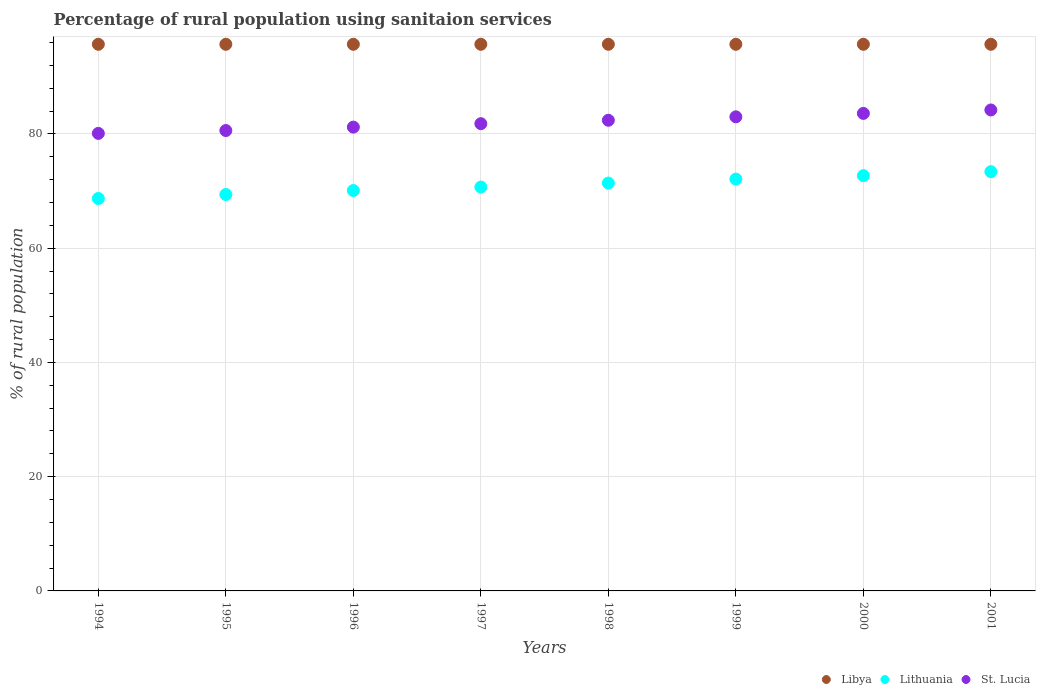What is the percentage of rural population using sanitaion services in Lithuania in 2001?
Your answer should be very brief. 73.4. Across all years, what is the maximum percentage of rural population using sanitaion services in St. Lucia?
Your answer should be very brief. 84.2. Across all years, what is the minimum percentage of rural population using sanitaion services in Libya?
Provide a short and direct response. 95.7. In which year was the percentage of rural population using sanitaion services in Libya maximum?
Your response must be concise. 1994. In which year was the percentage of rural population using sanitaion services in Lithuania minimum?
Give a very brief answer. 1994. What is the total percentage of rural population using sanitaion services in Libya in the graph?
Keep it short and to the point. 765.6. What is the difference between the percentage of rural population using sanitaion services in Lithuania in 1996 and that in 1997?
Ensure brevity in your answer.  -0.6. What is the difference between the percentage of rural population using sanitaion services in Lithuania in 1994 and the percentage of rural population using sanitaion services in St. Lucia in 1997?
Provide a succinct answer. -13.1. What is the average percentage of rural population using sanitaion services in St. Lucia per year?
Make the answer very short. 82.11. In the year 1995, what is the difference between the percentage of rural population using sanitaion services in Lithuania and percentage of rural population using sanitaion services in St. Lucia?
Ensure brevity in your answer.  -11.2. What is the ratio of the percentage of rural population using sanitaion services in Lithuania in 1994 to that in 1999?
Your answer should be compact. 0.95. Is the percentage of rural population using sanitaion services in Lithuania in 1995 less than that in 1997?
Provide a short and direct response. Yes. What is the difference between the highest and the second highest percentage of rural population using sanitaion services in St. Lucia?
Your answer should be very brief. 0.6. What is the difference between the highest and the lowest percentage of rural population using sanitaion services in Lithuania?
Provide a succinct answer. 4.7. Is the sum of the percentage of rural population using sanitaion services in Libya in 1994 and 2001 greater than the maximum percentage of rural population using sanitaion services in St. Lucia across all years?
Provide a succinct answer. Yes. Does the percentage of rural population using sanitaion services in Libya monotonically increase over the years?
Ensure brevity in your answer.  No. How many years are there in the graph?
Provide a succinct answer. 8. Are the values on the major ticks of Y-axis written in scientific E-notation?
Your answer should be very brief. No. Does the graph contain any zero values?
Offer a terse response. No. Does the graph contain grids?
Your response must be concise. Yes. Where does the legend appear in the graph?
Provide a succinct answer. Bottom right. How many legend labels are there?
Offer a terse response. 3. How are the legend labels stacked?
Provide a short and direct response. Horizontal. What is the title of the graph?
Offer a very short reply. Percentage of rural population using sanitaion services. What is the label or title of the X-axis?
Your response must be concise. Years. What is the label or title of the Y-axis?
Provide a succinct answer. % of rural population. What is the % of rural population of Libya in 1994?
Offer a terse response. 95.7. What is the % of rural population of Lithuania in 1994?
Offer a very short reply. 68.7. What is the % of rural population in St. Lucia in 1994?
Offer a terse response. 80.1. What is the % of rural population of Libya in 1995?
Give a very brief answer. 95.7. What is the % of rural population in Lithuania in 1995?
Your answer should be very brief. 69.4. What is the % of rural population of St. Lucia in 1995?
Provide a succinct answer. 80.6. What is the % of rural population of Libya in 1996?
Provide a short and direct response. 95.7. What is the % of rural population of Lithuania in 1996?
Your response must be concise. 70.1. What is the % of rural population in St. Lucia in 1996?
Your answer should be very brief. 81.2. What is the % of rural population in Libya in 1997?
Make the answer very short. 95.7. What is the % of rural population of Lithuania in 1997?
Your answer should be compact. 70.7. What is the % of rural population of St. Lucia in 1997?
Provide a succinct answer. 81.8. What is the % of rural population in Libya in 1998?
Keep it short and to the point. 95.7. What is the % of rural population of Lithuania in 1998?
Make the answer very short. 71.4. What is the % of rural population in St. Lucia in 1998?
Provide a succinct answer. 82.4. What is the % of rural population of Libya in 1999?
Offer a terse response. 95.7. What is the % of rural population in Lithuania in 1999?
Your answer should be very brief. 72.1. What is the % of rural population of Libya in 2000?
Your answer should be very brief. 95.7. What is the % of rural population in Lithuania in 2000?
Offer a terse response. 72.7. What is the % of rural population of St. Lucia in 2000?
Ensure brevity in your answer.  83.6. What is the % of rural population of Libya in 2001?
Offer a very short reply. 95.7. What is the % of rural population of Lithuania in 2001?
Provide a short and direct response. 73.4. What is the % of rural population in St. Lucia in 2001?
Ensure brevity in your answer.  84.2. Across all years, what is the maximum % of rural population in Libya?
Provide a short and direct response. 95.7. Across all years, what is the maximum % of rural population in Lithuania?
Your answer should be very brief. 73.4. Across all years, what is the maximum % of rural population of St. Lucia?
Provide a short and direct response. 84.2. Across all years, what is the minimum % of rural population in Libya?
Offer a very short reply. 95.7. Across all years, what is the minimum % of rural population of Lithuania?
Keep it short and to the point. 68.7. Across all years, what is the minimum % of rural population of St. Lucia?
Provide a short and direct response. 80.1. What is the total % of rural population of Libya in the graph?
Make the answer very short. 765.6. What is the total % of rural population of Lithuania in the graph?
Provide a succinct answer. 568.5. What is the total % of rural population of St. Lucia in the graph?
Your answer should be compact. 656.9. What is the difference between the % of rural population in Libya in 1994 and that in 1995?
Ensure brevity in your answer.  0. What is the difference between the % of rural population of St. Lucia in 1994 and that in 1995?
Your answer should be very brief. -0.5. What is the difference between the % of rural population of Libya in 1994 and that in 1997?
Make the answer very short. 0. What is the difference between the % of rural population in Lithuania in 1994 and that in 1998?
Give a very brief answer. -2.7. What is the difference between the % of rural population of Libya in 1994 and that in 1999?
Offer a terse response. 0. What is the difference between the % of rural population in Lithuania in 1994 and that in 1999?
Provide a short and direct response. -3.4. What is the difference between the % of rural population of Lithuania in 1994 and that in 2000?
Your answer should be compact. -4. What is the difference between the % of rural population in St. Lucia in 1994 and that in 2000?
Provide a succinct answer. -3.5. What is the difference between the % of rural population of St. Lucia in 1994 and that in 2001?
Provide a short and direct response. -4.1. What is the difference between the % of rural population in Libya in 1995 and that in 1996?
Ensure brevity in your answer.  0. What is the difference between the % of rural population of St. Lucia in 1995 and that in 1996?
Keep it short and to the point. -0.6. What is the difference between the % of rural population of Libya in 1995 and that in 1997?
Your answer should be compact. 0. What is the difference between the % of rural population of St. Lucia in 1995 and that in 1997?
Offer a very short reply. -1.2. What is the difference between the % of rural population of Libya in 1995 and that in 1998?
Your answer should be very brief. 0. What is the difference between the % of rural population of Lithuania in 1995 and that in 1998?
Your answer should be compact. -2. What is the difference between the % of rural population of St. Lucia in 1995 and that in 1998?
Offer a very short reply. -1.8. What is the difference between the % of rural population of Libya in 1995 and that in 1999?
Keep it short and to the point. 0. What is the difference between the % of rural population in St. Lucia in 1995 and that in 2000?
Offer a terse response. -3. What is the difference between the % of rural population of Libya in 1995 and that in 2001?
Offer a terse response. 0. What is the difference between the % of rural population of Lithuania in 1995 and that in 2001?
Ensure brevity in your answer.  -4. What is the difference between the % of rural population in Libya in 1996 and that in 1997?
Your answer should be very brief. 0. What is the difference between the % of rural population of Lithuania in 1996 and that in 1997?
Give a very brief answer. -0.6. What is the difference between the % of rural population of St. Lucia in 1996 and that in 1997?
Your answer should be very brief. -0.6. What is the difference between the % of rural population in Libya in 1996 and that in 1998?
Your answer should be compact. 0. What is the difference between the % of rural population of St. Lucia in 1996 and that in 1998?
Give a very brief answer. -1.2. What is the difference between the % of rural population in Libya in 1996 and that in 1999?
Ensure brevity in your answer.  0. What is the difference between the % of rural population in St. Lucia in 1996 and that in 1999?
Provide a succinct answer. -1.8. What is the difference between the % of rural population in St. Lucia in 1996 and that in 2000?
Provide a short and direct response. -2.4. What is the difference between the % of rural population in Libya in 1996 and that in 2001?
Your response must be concise. 0. What is the difference between the % of rural population of St. Lucia in 1996 and that in 2001?
Your response must be concise. -3. What is the difference between the % of rural population of Libya in 1997 and that in 1998?
Provide a succinct answer. 0. What is the difference between the % of rural population of St. Lucia in 1997 and that in 1998?
Your response must be concise. -0.6. What is the difference between the % of rural population of Libya in 1997 and that in 1999?
Keep it short and to the point. 0. What is the difference between the % of rural population of Libya in 1997 and that in 2000?
Your answer should be very brief. 0. What is the difference between the % of rural population in St. Lucia in 1997 and that in 2000?
Keep it short and to the point. -1.8. What is the difference between the % of rural population in Lithuania in 1997 and that in 2001?
Offer a terse response. -2.7. What is the difference between the % of rural population in Libya in 1998 and that in 1999?
Keep it short and to the point. 0. What is the difference between the % of rural population of Lithuania in 1998 and that in 1999?
Ensure brevity in your answer.  -0.7. What is the difference between the % of rural population in Libya in 1998 and that in 2000?
Make the answer very short. 0. What is the difference between the % of rural population in St. Lucia in 1998 and that in 2000?
Your response must be concise. -1.2. What is the difference between the % of rural population of St. Lucia in 1998 and that in 2001?
Make the answer very short. -1.8. What is the difference between the % of rural population in Libya in 1999 and that in 2000?
Your answer should be very brief. 0. What is the difference between the % of rural population of Libya in 1999 and that in 2001?
Offer a terse response. 0. What is the difference between the % of rural population of Lithuania in 1999 and that in 2001?
Offer a very short reply. -1.3. What is the difference between the % of rural population in Libya in 1994 and the % of rural population in Lithuania in 1995?
Give a very brief answer. 26.3. What is the difference between the % of rural population in Libya in 1994 and the % of rural population in St. Lucia in 1995?
Your answer should be very brief. 15.1. What is the difference between the % of rural population of Lithuania in 1994 and the % of rural population of St. Lucia in 1995?
Your answer should be compact. -11.9. What is the difference between the % of rural population of Libya in 1994 and the % of rural population of Lithuania in 1996?
Give a very brief answer. 25.6. What is the difference between the % of rural population of Lithuania in 1994 and the % of rural population of St. Lucia in 1997?
Your answer should be compact. -13.1. What is the difference between the % of rural population of Libya in 1994 and the % of rural population of Lithuania in 1998?
Make the answer very short. 24.3. What is the difference between the % of rural population of Libya in 1994 and the % of rural population of St. Lucia in 1998?
Offer a very short reply. 13.3. What is the difference between the % of rural population in Lithuania in 1994 and the % of rural population in St. Lucia in 1998?
Provide a succinct answer. -13.7. What is the difference between the % of rural population of Libya in 1994 and the % of rural population of Lithuania in 1999?
Your answer should be compact. 23.6. What is the difference between the % of rural population of Lithuania in 1994 and the % of rural population of St. Lucia in 1999?
Your response must be concise. -14.3. What is the difference between the % of rural population in Lithuania in 1994 and the % of rural population in St. Lucia in 2000?
Ensure brevity in your answer.  -14.9. What is the difference between the % of rural population in Libya in 1994 and the % of rural population in Lithuania in 2001?
Make the answer very short. 22.3. What is the difference between the % of rural population of Lithuania in 1994 and the % of rural population of St. Lucia in 2001?
Give a very brief answer. -15.5. What is the difference between the % of rural population of Libya in 1995 and the % of rural population of Lithuania in 1996?
Your answer should be very brief. 25.6. What is the difference between the % of rural population in Libya in 1995 and the % of rural population in St. Lucia in 1996?
Offer a terse response. 14.5. What is the difference between the % of rural population in Lithuania in 1995 and the % of rural population in St. Lucia in 1996?
Offer a terse response. -11.8. What is the difference between the % of rural population in Libya in 1995 and the % of rural population in Lithuania in 1997?
Provide a succinct answer. 25. What is the difference between the % of rural population of Libya in 1995 and the % of rural population of Lithuania in 1998?
Your response must be concise. 24.3. What is the difference between the % of rural population in Libya in 1995 and the % of rural population in Lithuania in 1999?
Your response must be concise. 23.6. What is the difference between the % of rural population of Lithuania in 1995 and the % of rural population of St. Lucia in 1999?
Your response must be concise. -13.6. What is the difference between the % of rural population of Libya in 1995 and the % of rural population of Lithuania in 2000?
Give a very brief answer. 23. What is the difference between the % of rural population in Libya in 1995 and the % of rural population in Lithuania in 2001?
Ensure brevity in your answer.  22.3. What is the difference between the % of rural population of Libya in 1995 and the % of rural population of St. Lucia in 2001?
Keep it short and to the point. 11.5. What is the difference between the % of rural population of Lithuania in 1995 and the % of rural population of St. Lucia in 2001?
Ensure brevity in your answer.  -14.8. What is the difference between the % of rural population of Libya in 1996 and the % of rural population of Lithuania in 1997?
Your answer should be compact. 25. What is the difference between the % of rural population in Libya in 1996 and the % of rural population in St. Lucia in 1997?
Provide a succinct answer. 13.9. What is the difference between the % of rural population of Lithuania in 1996 and the % of rural population of St. Lucia in 1997?
Offer a very short reply. -11.7. What is the difference between the % of rural population in Libya in 1996 and the % of rural population in Lithuania in 1998?
Make the answer very short. 24.3. What is the difference between the % of rural population of Libya in 1996 and the % of rural population of Lithuania in 1999?
Provide a succinct answer. 23.6. What is the difference between the % of rural population of Libya in 1996 and the % of rural population of St. Lucia in 1999?
Provide a short and direct response. 12.7. What is the difference between the % of rural population of Lithuania in 1996 and the % of rural population of St. Lucia in 1999?
Your answer should be very brief. -12.9. What is the difference between the % of rural population in Lithuania in 1996 and the % of rural population in St. Lucia in 2000?
Provide a succinct answer. -13.5. What is the difference between the % of rural population of Libya in 1996 and the % of rural population of Lithuania in 2001?
Your answer should be very brief. 22.3. What is the difference between the % of rural population in Lithuania in 1996 and the % of rural population in St. Lucia in 2001?
Your answer should be compact. -14.1. What is the difference between the % of rural population in Libya in 1997 and the % of rural population in Lithuania in 1998?
Give a very brief answer. 24.3. What is the difference between the % of rural population in Libya in 1997 and the % of rural population in Lithuania in 1999?
Your response must be concise. 23.6. What is the difference between the % of rural population of Libya in 1997 and the % of rural population of St. Lucia in 2000?
Give a very brief answer. 12.1. What is the difference between the % of rural population of Libya in 1997 and the % of rural population of Lithuania in 2001?
Make the answer very short. 22.3. What is the difference between the % of rural population of Libya in 1997 and the % of rural population of St. Lucia in 2001?
Offer a terse response. 11.5. What is the difference between the % of rural population of Lithuania in 1997 and the % of rural population of St. Lucia in 2001?
Your answer should be compact. -13.5. What is the difference between the % of rural population of Libya in 1998 and the % of rural population of Lithuania in 1999?
Offer a terse response. 23.6. What is the difference between the % of rural population in Libya in 1998 and the % of rural population in St. Lucia in 1999?
Offer a very short reply. 12.7. What is the difference between the % of rural population of Lithuania in 1998 and the % of rural population of St. Lucia in 1999?
Ensure brevity in your answer.  -11.6. What is the difference between the % of rural population in Libya in 1998 and the % of rural population in Lithuania in 2000?
Your response must be concise. 23. What is the difference between the % of rural population of Libya in 1998 and the % of rural population of Lithuania in 2001?
Keep it short and to the point. 22.3. What is the difference between the % of rural population of Libya in 1998 and the % of rural population of St. Lucia in 2001?
Provide a succinct answer. 11.5. What is the difference between the % of rural population of Lithuania in 1998 and the % of rural population of St. Lucia in 2001?
Provide a succinct answer. -12.8. What is the difference between the % of rural population in Libya in 1999 and the % of rural population in Lithuania in 2000?
Your response must be concise. 23. What is the difference between the % of rural population in Libya in 1999 and the % of rural population in Lithuania in 2001?
Your answer should be compact. 22.3. What is the difference between the % of rural population of Lithuania in 1999 and the % of rural population of St. Lucia in 2001?
Your answer should be very brief. -12.1. What is the difference between the % of rural population in Libya in 2000 and the % of rural population in Lithuania in 2001?
Your answer should be compact. 22.3. What is the difference between the % of rural population of Libya in 2000 and the % of rural population of St. Lucia in 2001?
Offer a very short reply. 11.5. What is the average % of rural population in Libya per year?
Offer a very short reply. 95.7. What is the average % of rural population of Lithuania per year?
Give a very brief answer. 71.06. What is the average % of rural population of St. Lucia per year?
Give a very brief answer. 82.11. In the year 1994, what is the difference between the % of rural population in Libya and % of rural population in St. Lucia?
Your response must be concise. 15.6. In the year 1995, what is the difference between the % of rural population in Libya and % of rural population in Lithuania?
Your response must be concise. 26.3. In the year 1996, what is the difference between the % of rural population of Libya and % of rural population of Lithuania?
Make the answer very short. 25.6. In the year 1996, what is the difference between the % of rural population in Libya and % of rural population in St. Lucia?
Give a very brief answer. 14.5. In the year 1996, what is the difference between the % of rural population of Lithuania and % of rural population of St. Lucia?
Provide a succinct answer. -11.1. In the year 1997, what is the difference between the % of rural population of Libya and % of rural population of St. Lucia?
Your response must be concise. 13.9. In the year 1998, what is the difference between the % of rural population in Libya and % of rural population in Lithuania?
Your response must be concise. 24.3. In the year 1999, what is the difference between the % of rural population of Libya and % of rural population of Lithuania?
Provide a short and direct response. 23.6. In the year 1999, what is the difference between the % of rural population in Libya and % of rural population in St. Lucia?
Offer a terse response. 12.7. In the year 2000, what is the difference between the % of rural population in Libya and % of rural population in St. Lucia?
Offer a terse response. 12.1. In the year 2000, what is the difference between the % of rural population in Lithuania and % of rural population in St. Lucia?
Offer a very short reply. -10.9. In the year 2001, what is the difference between the % of rural population of Libya and % of rural population of Lithuania?
Your answer should be compact. 22.3. In the year 2001, what is the difference between the % of rural population in Libya and % of rural population in St. Lucia?
Make the answer very short. 11.5. What is the ratio of the % of rural population of Lithuania in 1994 to that in 1995?
Provide a succinct answer. 0.99. What is the ratio of the % of rural population in Lithuania in 1994 to that in 1996?
Provide a short and direct response. 0.98. What is the ratio of the % of rural population of St. Lucia in 1994 to that in 1996?
Your answer should be compact. 0.99. What is the ratio of the % of rural population of Libya in 1994 to that in 1997?
Your response must be concise. 1. What is the ratio of the % of rural population in Lithuania in 1994 to that in 1997?
Ensure brevity in your answer.  0.97. What is the ratio of the % of rural population of St. Lucia in 1994 to that in 1997?
Provide a succinct answer. 0.98. What is the ratio of the % of rural population of Libya in 1994 to that in 1998?
Your answer should be compact. 1. What is the ratio of the % of rural population of Lithuania in 1994 to that in 1998?
Your answer should be compact. 0.96. What is the ratio of the % of rural population in St. Lucia in 1994 to that in 1998?
Provide a short and direct response. 0.97. What is the ratio of the % of rural population of Lithuania in 1994 to that in 1999?
Your answer should be compact. 0.95. What is the ratio of the % of rural population of St. Lucia in 1994 to that in 1999?
Make the answer very short. 0.97. What is the ratio of the % of rural population of Lithuania in 1994 to that in 2000?
Provide a short and direct response. 0.94. What is the ratio of the % of rural population in St. Lucia in 1994 to that in 2000?
Keep it short and to the point. 0.96. What is the ratio of the % of rural population in Libya in 1994 to that in 2001?
Ensure brevity in your answer.  1. What is the ratio of the % of rural population in Lithuania in 1994 to that in 2001?
Your answer should be very brief. 0.94. What is the ratio of the % of rural population in St. Lucia in 1994 to that in 2001?
Ensure brevity in your answer.  0.95. What is the ratio of the % of rural population of Lithuania in 1995 to that in 1996?
Make the answer very short. 0.99. What is the ratio of the % of rural population of St. Lucia in 1995 to that in 1996?
Provide a succinct answer. 0.99. What is the ratio of the % of rural population of Lithuania in 1995 to that in 1997?
Offer a very short reply. 0.98. What is the ratio of the % of rural population of Libya in 1995 to that in 1998?
Make the answer very short. 1. What is the ratio of the % of rural population in St. Lucia in 1995 to that in 1998?
Offer a terse response. 0.98. What is the ratio of the % of rural population of Lithuania in 1995 to that in 1999?
Make the answer very short. 0.96. What is the ratio of the % of rural population in St. Lucia in 1995 to that in 1999?
Give a very brief answer. 0.97. What is the ratio of the % of rural population in Libya in 1995 to that in 2000?
Your answer should be compact. 1. What is the ratio of the % of rural population in Lithuania in 1995 to that in 2000?
Give a very brief answer. 0.95. What is the ratio of the % of rural population of St. Lucia in 1995 to that in 2000?
Give a very brief answer. 0.96. What is the ratio of the % of rural population in Libya in 1995 to that in 2001?
Provide a short and direct response. 1. What is the ratio of the % of rural population in Lithuania in 1995 to that in 2001?
Provide a short and direct response. 0.95. What is the ratio of the % of rural population of St. Lucia in 1995 to that in 2001?
Ensure brevity in your answer.  0.96. What is the ratio of the % of rural population in Libya in 1996 to that in 1998?
Make the answer very short. 1. What is the ratio of the % of rural population in Lithuania in 1996 to that in 1998?
Your answer should be compact. 0.98. What is the ratio of the % of rural population of St. Lucia in 1996 to that in 1998?
Make the answer very short. 0.99. What is the ratio of the % of rural population of Libya in 1996 to that in 1999?
Offer a terse response. 1. What is the ratio of the % of rural population in Lithuania in 1996 to that in 1999?
Offer a terse response. 0.97. What is the ratio of the % of rural population of St. Lucia in 1996 to that in 1999?
Your answer should be compact. 0.98. What is the ratio of the % of rural population in Libya in 1996 to that in 2000?
Keep it short and to the point. 1. What is the ratio of the % of rural population of Lithuania in 1996 to that in 2000?
Provide a succinct answer. 0.96. What is the ratio of the % of rural population of St. Lucia in 1996 to that in 2000?
Offer a very short reply. 0.97. What is the ratio of the % of rural population in Lithuania in 1996 to that in 2001?
Offer a very short reply. 0.95. What is the ratio of the % of rural population in St. Lucia in 1996 to that in 2001?
Ensure brevity in your answer.  0.96. What is the ratio of the % of rural population in Lithuania in 1997 to that in 1998?
Make the answer very short. 0.99. What is the ratio of the % of rural population in Libya in 1997 to that in 1999?
Your response must be concise. 1. What is the ratio of the % of rural population in Lithuania in 1997 to that in 1999?
Your answer should be very brief. 0.98. What is the ratio of the % of rural population of St. Lucia in 1997 to that in 1999?
Offer a terse response. 0.99. What is the ratio of the % of rural population of Libya in 1997 to that in 2000?
Keep it short and to the point. 1. What is the ratio of the % of rural population of Lithuania in 1997 to that in 2000?
Offer a very short reply. 0.97. What is the ratio of the % of rural population in St. Lucia in 1997 to that in 2000?
Give a very brief answer. 0.98. What is the ratio of the % of rural population in Libya in 1997 to that in 2001?
Ensure brevity in your answer.  1. What is the ratio of the % of rural population of Lithuania in 1997 to that in 2001?
Provide a short and direct response. 0.96. What is the ratio of the % of rural population in St. Lucia in 1997 to that in 2001?
Provide a short and direct response. 0.97. What is the ratio of the % of rural population of Libya in 1998 to that in 1999?
Your answer should be compact. 1. What is the ratio of the % of rural population in Lithuania in 1998 to that in 1999?
Make the answer very short. 0.99. What is the ratio of the % of rural population in Lithuania in 1998 to that in 2000?
Provide a short and direct response. 0.98. What is the ratio of the % of rural population in St. Lucia in 1998 to that in 2000?
Make the answer very short. 0.99. What is the ratio of the % of rural population of Lithuania in 1998 to that in 2001?
Your answer should be very brief. 0.97. What is the ratio of the % of rural population of St. Lucia in 1998 to that in 2001?
Provide a succinct answer. 0.98. What is the ratio of the % of rural population of Lithuania in 1999 to that in 2000?
Your response must be concise. 0.99. What is the ratio of the % of rural population of Libya in 1999 to that in 2001?
Ensure brevity in your answer.  1. What is the ratio of the % of rural population of Lithuania in 1999 to that in 2001?
Ensure brevity in your answer.  0.98. What is the ratio of the % of rural population of St. Lucia in 1999 to that in 2001?
Provide a short and direct response. 0.99. What is the ratio of the % of rural population of Lithuania in 2000 to that in 2001?
Provide a short and direct response. 0.99. What is the difference between the highest and the second highest % of rural population of St. Lucia?
Make the answer very short. 0.6. 